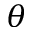<formula> <loc_0><loc_0><loc_500><loc_500>\theta</formula> 